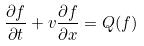<formula> <loc_0><loc_0><loc_500><loc_500>\frac { \partial f } { \partial t } + v \frac { \partial f } { \partial x } = Q ( f )</formula> 